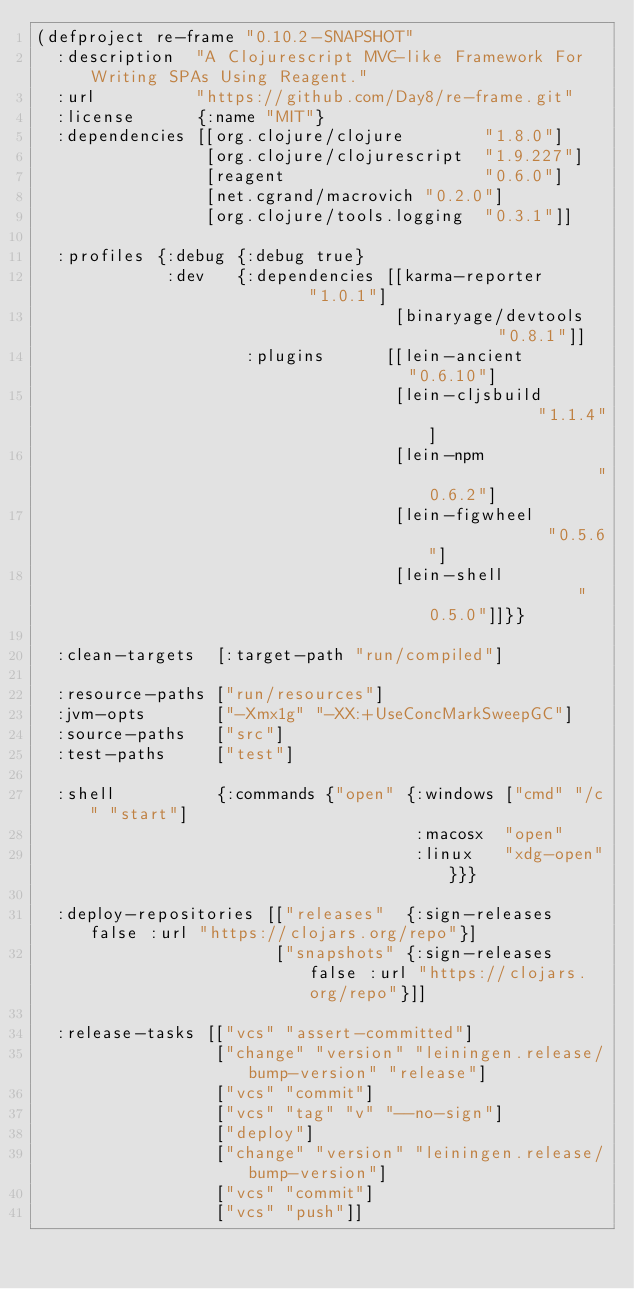<code> <loc_0><loc_0><loc_500><loc_500><_Clojure_>(defproject re-frame "0.10.2-SNAPSHOT"
  :description  "A Clojurescript MVC-like Framework For Writing SPAs Using Reagent."
  :url          "https://github.com/Day8/re-frame.git"
  :license      {:name "MIT"}
  :dependencies [[org.clojure/clojure        "1.8.0"]
                 [org.clojure/clojurescript  "1.9.227"]
                 [reagent                    "0.6.0"]
                 [net.cgrand/macrovich "0.2.0"]
                 [org.clojure/tools.logging  "0.3.1"]]

  :profiles {:debug {:debug true}
             :dev   {:dependencies [[karma-reporter            "1.0.1"]
                                    [binaryage/devtools        "0.8.1"]]
                     :plugins      [[lein-ancient              "0.6.10"]
                                    [lein-cljsbuild            "1.1.4"]
                                    [lein-npm                  "0.6.2"]
                                    [lein-figwheel             "0.5.6"]
                                    [lein-shell                "0.5.0"]]}}

  :clean-targets  [:target-path "run/compiled"]

  :resource-paths ["run/resources"]
  :jvm-opts       ["-Xmx1g" "-XX:+UseConcMarkSweepGC"]
  :source-paths   ["src"]
  :test-paths     ["test"]

  :shell          {:commands {"open" {:windows ["cmd" "/c" "start"]
                                      :macosx  "open"
                                      :linux   "xdg-open"}}}

  :deploy-repositories [["releases"  {:sign-releases false :url "https://clojars.org/repo"}]
                        ["snapshots" {:sign-releases false :url "https://clojars.org/repo"}]]

  :release-tasks [["vcs" "assert-committed"]
                  ["change" "version" "leiningen.release/bump-version" "release"]
                  ["vcs" "commit"]
                  ["vcs" "tag" "v" "--no-sign"]
                  ["deploy"]
                  ["change" "version" "leiningen.release/bump-version"]
                  ["vcs" "commit"]
                  ["vcs" "push"]]
</code> 